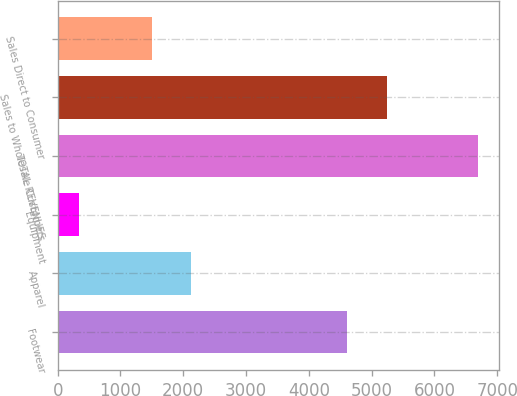<chart> <loc_0><loc_0><loc_500><loc_500><bar_chart><fcel>Footwear<fcel>Apparel<fcel>Equipment<fcel>TOTAL REVENUES<fcel>Sales to Wholesale Customers<fcel>Sales Direct to Consumer<nl><fcel>4611<fcel>2130.1<fcel>346<fcel>6697<fcel>5246.1<fcel>1495<nl></chart> 